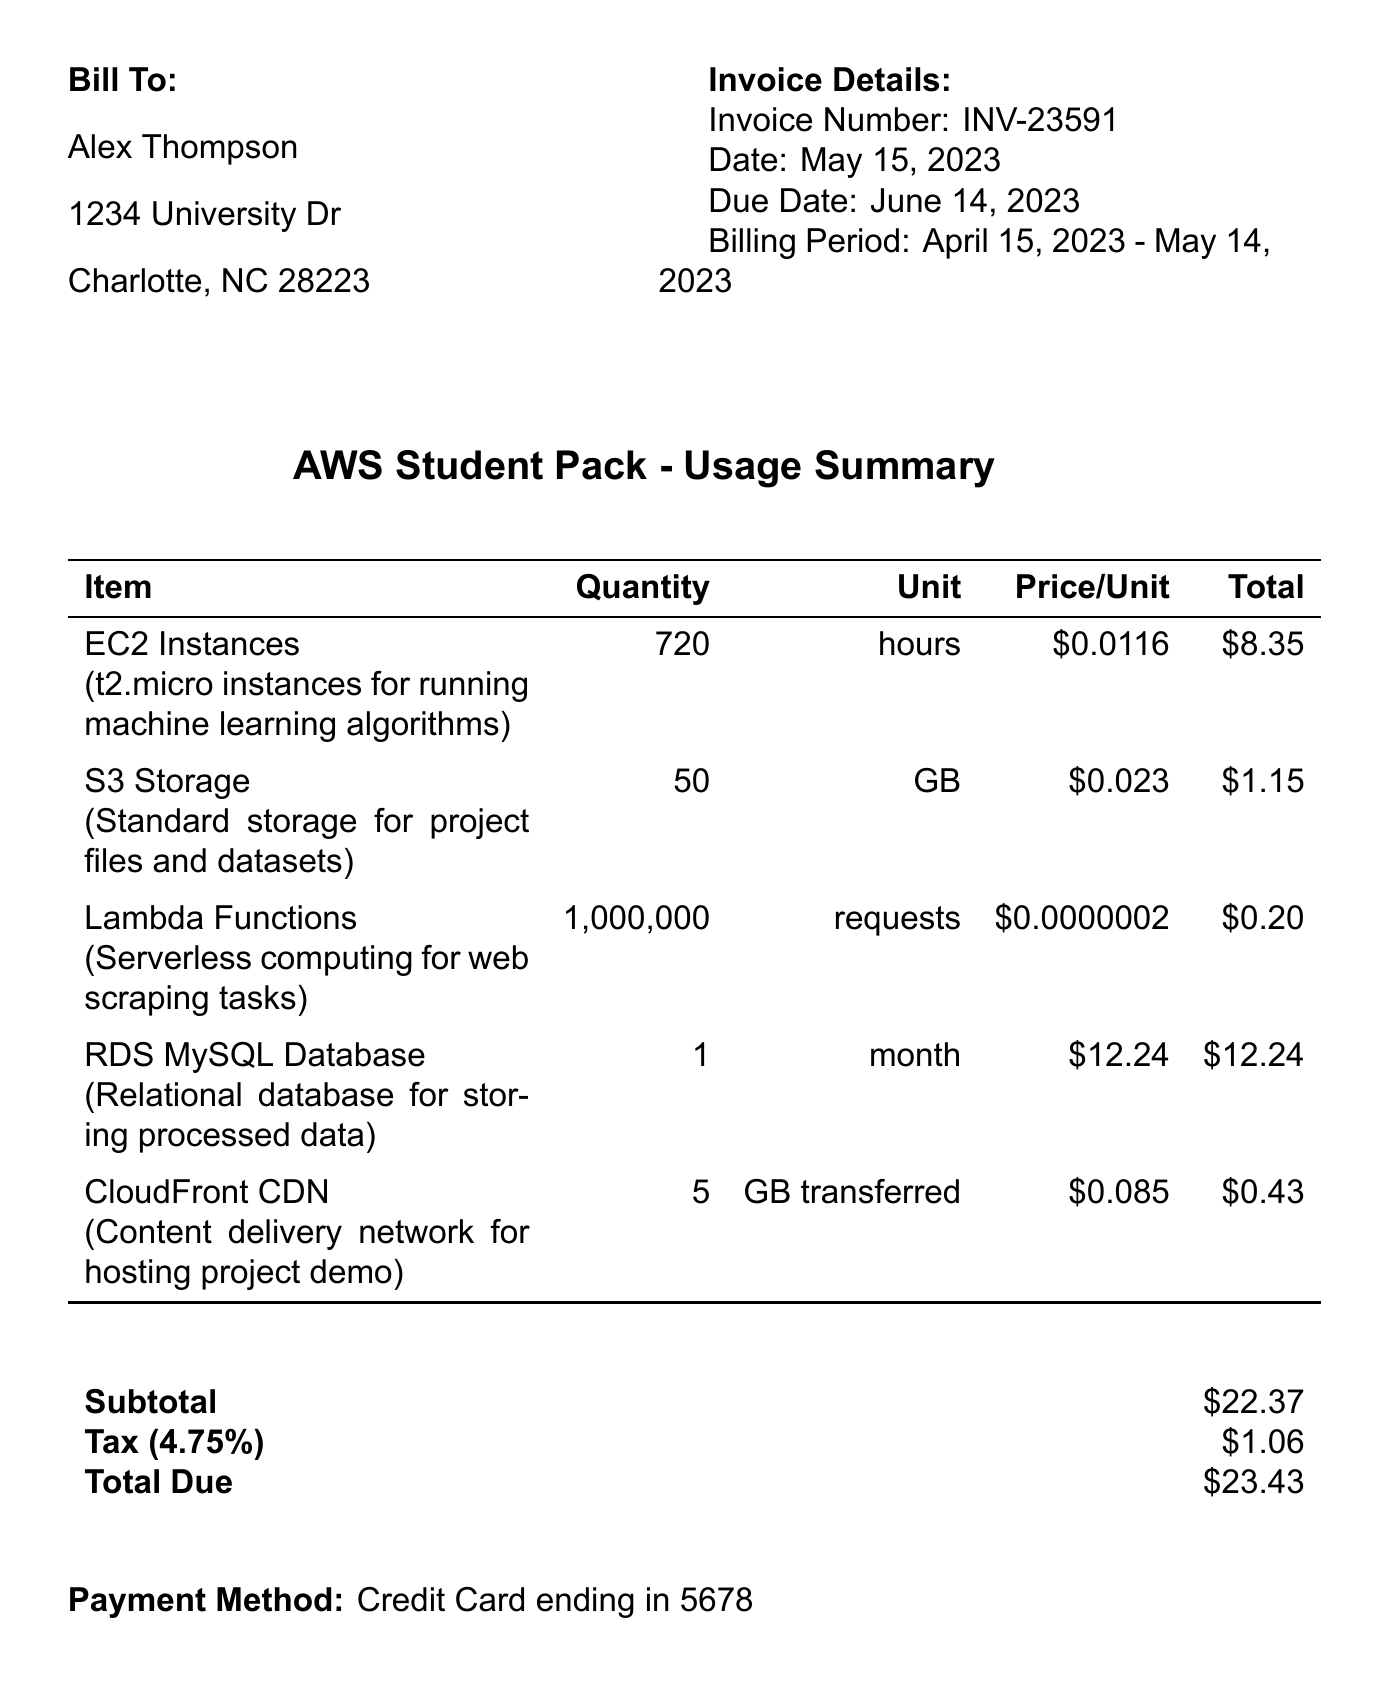What is the invoice number? The invoice number is listed in the document as a unique identifier for this invoice.
Answer: INV-23591 Who is the customer? The customer's name is provided at the beginning of the invoice.
Answer: Alex Thompson What is the billing period? The billing period indicates the date range for which services are provided and is noted in the invoice details.
Answer: April 15, 2023 - May 14, 2023 How much is the total due? The total due is the final amount to be paid as stated in the invoice.
Answer: $23.43 What is the quantity of EC2 Instances used? The quantity of EC2 Instances is specified as part of the usage summary for this subscription.
Answer: 720 What is the tax amount? The tax amount refers to the additional charge applied to the subtotal based on the tax rate provided in the invoice.
Answer: $1.06 What are AWS Educate credits applied? The invoice includes notes about credits that have been applied to the account.
Answer: $100.00 What is the payment method? The payment method used for this invoice is specified in the payments section.
Answer: Credit Card ending in 5678 What subscription plan is used? The subscription plan details the type of service and benefits received as stated in the document.
Answer: AWS Student Pack 